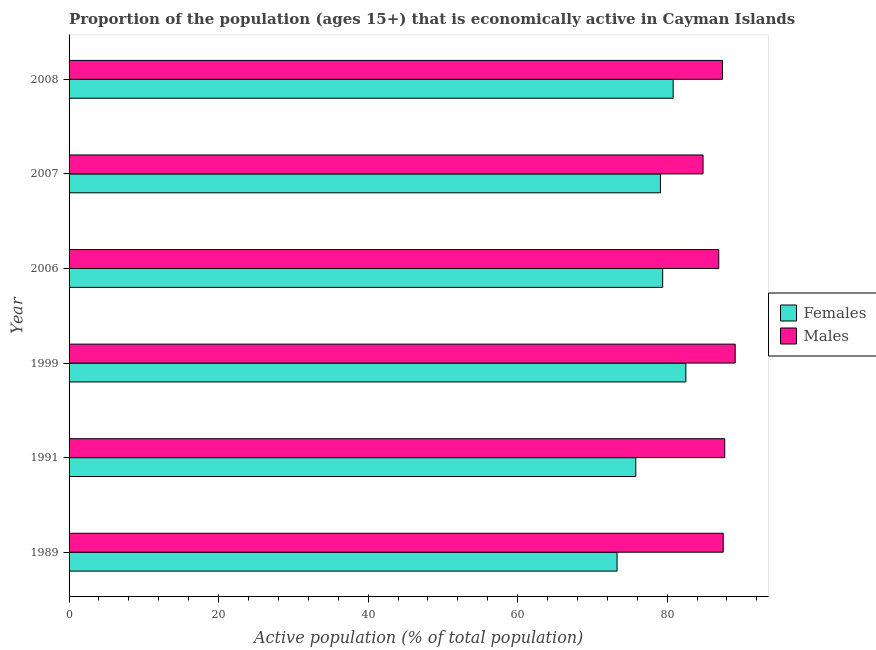How many groups of bars are there?
Offer a very short reply. 6. Are the number of bars on each tick of the Y-axis equal?
Ensure brevity in your answer.  Yes. How many bars are there on the 6th tick from the bottom?
Make the answer very short. 2. What is the percentage of economically active female population in 1991?
Provide a short and direct response. 75.8. Across all years, what is the maximum percentage of economically active male population?
Offer a terse response. 89.1. Across all years, what is the minimum percentage of economically active male population?
Ensure brevity in your answer.  84.8. In which year was the percentage of economically active male population minimum?
Offer a terse response. 2007. What is the total percentage of economically active male population in the graph?
Keep it short and to the point. 523.4. What is the difference between the percentage of economically active female population in 1989 and that in 2007?
Your answer should be compact. -5.8. What is the difference between the percentage of economically active female population in 2006 and the percentage of economically active male population in 2007?
Give a very brief answer. -5.4. What is the average percentage of economically active female population per year?
Your answer should be very brief. 78.48. In the year 1991, what is the difference between the percentage of economically active female population and percentage of economically active male population?
Offer a very short reply. -11.9. In how many years, is the percentage of economically active male population greater than 20 %?
Ensure brevity in your answer.  6. What is the ratio of the percentage of economically active female population in 1991 to that in 2008?
Your answer should be very brief. 0.94. Is the percentage of economically active male population in 1989 less than that in 1991?
Provide a short and direct response. Yes. What is the difference between the highest and the second highest percentage of economically active male population?
Offer a very short reply. 1.4. In how many years, is the percentage of economically active female population greater than the average percentage of economically active female population taken over all years?
Your answer should be very brief. 4. Is the sum of the percentage of economically active male population in 1991 and 2008 greater than the maximum percentage of economically active female population across all years?
Offer a very short reply. Yes. What does the 2nd bar from the top in 1991 represents?
Your answer should be very brief. Females. What does the 1st bar from the bottom in 2007 represents?
Provide a succinct answer. Females. How many years are there in the graph?
Keep it short and to the point. 6. What is the difference between two consecutive major ticks on the X-axis?
Provide a short and direct response. 20. Does the graph contain any zero values?
Offer a very short reply. No. Where does the legend appear in the graph?
Offer a very short reply. Center right. What is the title of the graph?
Your response must be concise. Proportion of the population (ages 15+) that is economically active in Cayman Islands. Does "Borrowers" appear as one of the legend labels in the graph?
Provide a succinct answer. No. What is the label or title of the X-axis?
Your response must be concise. Active population (% of total population). What is the Active population (% of total population) of Females in 1989?
Your answer should be very brief. 73.3. What is the Active population (% of total population) in Males in 1989?
Make the answer very short. 87.5. What is the Active population (% of total population) in Females in 1991?
Ensure brevity in your answer.  75.8. What is the Active population (% of total population) in Males in 1991?
Make the answer very short. 87.7. What is the Active population (% of total population) of Females in 1999?
Your response must be concise. 82.5. What is the Active population (% of total population) in Males in 1999?
Give a very brief answer. 89.1. What is the Active population (% of total population) of Females in 2006?
Provide a short and direct response. 79.4. What is the Active population (% of total population) in Males in 2006?
Keep it short and to the point. 86.9. What is the Active population (% of total population) in Females in 2007?
Your answer should be compact. 79.1. What is the Active population (% of total population) of Males in 2007?
Offer a very short reply. 84.8. What is the Active population (% of total population) of Females in 2008?
Give a very brief answer. 80.8. What is the Active population (% of total population) in Males in 2008?
Your answer should be compact. 87.4. Across all years, what is the maximum Active population (% of total population) in Females?
Provide a succinct answer. 82.5. Across all years, what is the maximum Active population (% of total population) of Males?
Offer a very short reply. 89.1. Across all years, what is the minimum Active population (% of total population) of Females?
Offer a very short reply. 73.3. Across all years, what is the minimum Active population (% of total population) of Males?
Your answer should be very brief. 84.8. What is the total Active population (% of total population) of Females in the graph?
Your response must be concise. 470.9. What is the total Active population (% of total population) of Males in the graph?
Give a very brief answer. 523.4. What is the difference between the Active population (% of total population) in Females in 1989 and that in 2006?
Offer a terse response. -6.1. What is the difference between the Active population (% of total population) in Males in 1989 and that in 2006?
Provide a short and direct response. 0.6. What is the difference between the Active population (% of total population) in Females in 1989 and that in 2007?
Make the answer very short. -5.8. What is the difference between the Active population (% of total population) of Females in 1989 and that in 2008?
Provide a succinct answer. -7.5. What is the difference between the Active population (% of total population) in Females in 1991 and that in 1999?
Your response must be concise. -6.7. What is the difference between the Active population (% of total population) in Males in 1991 and that in 1999?
Give a very brief answer. -1.4. What is the difference between the Active population (% of total population) in Females in 1991 and that in 2006?
Make the answer very short. -3.6. What is the difference between the Active population (% of total population) in Males in 1991 and that in 2006?
Your answer should be very brief. 0.8. What is the difference between the Active population (% of total population) of Males in 1991 and that in 2007?
Make the answer very short. 2.9. What is the difference between the Active population (% of total population) in Males in 1999 and that in 2006?
Make the answer very short. 2.2. What is the difference between the Active population (% of total population) in Females in 1999 and that in 2007?
Ensure brevity in your answer.  3.4. What is the difference between the Active population (% of total population) in Females in 1999 and that in 2008?
Keep it short and to the point. 1.7. What is the difference between the Active population (% of total population) of Males in 1999 and that in 2008?
Provide a succinct answer. 1.7. What is the difference between the Active population (% of total population) of Females in 2006 and that in 2007?
Provide a short and direct response. 0.3. What is the difference between the Active population (% of total population) in Females in 2006 and that in 2008?
Offer a very short reply. -1.4. What is the difference between the Active population (% of total population) of Males in 2006 and that in 2008?
Offer a terse response. -0.5. What is the difference between the Active population (% of total population) of Males in 2007 and that in 2008?
Make the answer very short. -2.6. What is the difference between the Active population (% of total population) in Females in 1989 and the Active population (% of total population) in Males in 1991?
Ensure brevity in your answer.  -14.4. What is the difference between the Active population (% of total population) in Females in 1989 and the Active population (% of total population) in Males in 1999?
Provide a succinct answer. -15.8. What is the difference between the Active population (% of total population) in Females in 1989 and the Active population (% of total population) in Males in 2008?
Give a very brief answer. -14.1. What is the difference between the Active population (% of total population) in Females in 1999 and the Active population (% of total population) in Males in 2006?
Ensure brevity in your answer.  -4.4. What is the difference between the Active population (% of total population) in Females in 2006 and the Active population (% of total population) in Males in 2007?
Offer a terse response. -5.4. What is the difference between the Active population (% of total population) in Females in 2006 and the Active population (% of total population) in Males in 2008?
Offer a terse response. -8. What is the difference between the Active population (% of total population) in Females in 2007 and the Active population (% of total population) in Males in 2008?
Offer a terse response. -8.3. What is the average Active population (% of total population) of Females per year?
Give a very brief answer. 78.48. What is the average Active population (% of total population) of Males per year?
Offer a very short reply. 87.23. In the year 2006, what is the difference between the Active population (% of total population) in Females and Active population (% of total population) in Males?
Provide a succinct answer. -7.5. What is the ratio of the Active population (% of total population) of Females in 1989 to that in 1991?
Your response must be concise. 0.97. What is the ratio of the Active population (% of total population) of Females in 1989 to that in 1999?
Offer a terse response. 0.89. What is the ratio of the Active population (% of total population) of Females in 1989 to that in 2006?
Your response must be concise. 0.92. What is the ratio of the Active population (% of total population) in Females in 1989 to that in 2007?
Your response must be concise. 0.93. What is the ratio of the Active population (% of total population) in Males in 1989 to that in 2007?
Provide a succinct answer. 1.03. What is the ratio of the Active population (% of total population) in Females in 1989 to that in 2008?
Ensure brevity in your answer.  0.91. What is the ratio of the Active population (% of total population) of Females in 1991 to that in 1999?
Provide a succinct answer. 0.92. What is the ratio of the Active population (% of total population) of Males in 1991 to that in 1999?
Your answer should be compact. 0.98. What is the ratio of the Active population (% of total population) of Females in 1991 to that in 2006?
Your answer should be compact. 0.95. What is the ratio of the Active population (% of total population) in Males in 1991 to that in 2006?
Offer a very short reply. 1.01. What is the ratio of the Active population (% of total population) of Females in 1991 to that in 2007?
Keep it short and to the point. 0.96. What is the ratio of the Active population (% of total population) in Males in 1991 to that in 2007?
Ensure brevity in your answer.  1.03. What is the ratio of the Active population (% of total population) of Females in 1991 to that in 2008?
Your answer should be very brief. 0.94. What is the ratio of the Active population (% of total population) in Females in 1999 to that in 2006?
Keep it short and to the point. 1.04. What is the ratio of the Active population (% of total population) of Males in 1999 to that in 2006?
Provide a short and direct response. 1.03. What is the ratio of the Active population (% of total population) in Females in 1999 to that in 2007?
Provide a succinct answer. 1.04. What is the ratio of the Active population (% of total population) of Males in 1999 to that in 2007?
Your response must be concise. 1.05. What is the ratio of the Active population (% of total population) of Males in 1999 to that in 2008?
Your answer should be compact. 1.02. What is the ratio of the Active population (% of total population) of Males in 2006 to that in 2007?
Ensure brevity in your answer.  1.02. What is the ratio of the Active population (% of total population) in Females in 2006 to that in 2008?
Offer a very short reply. 0.98. What is the ratio of the Active population (% of total population) of Males in 2007 to that in 2008?
Make the answer very short. 0.97. What is the difference between the highest and the lowest Active population (% of total population) in Females?
Provide a succinct answer. 9.2. 